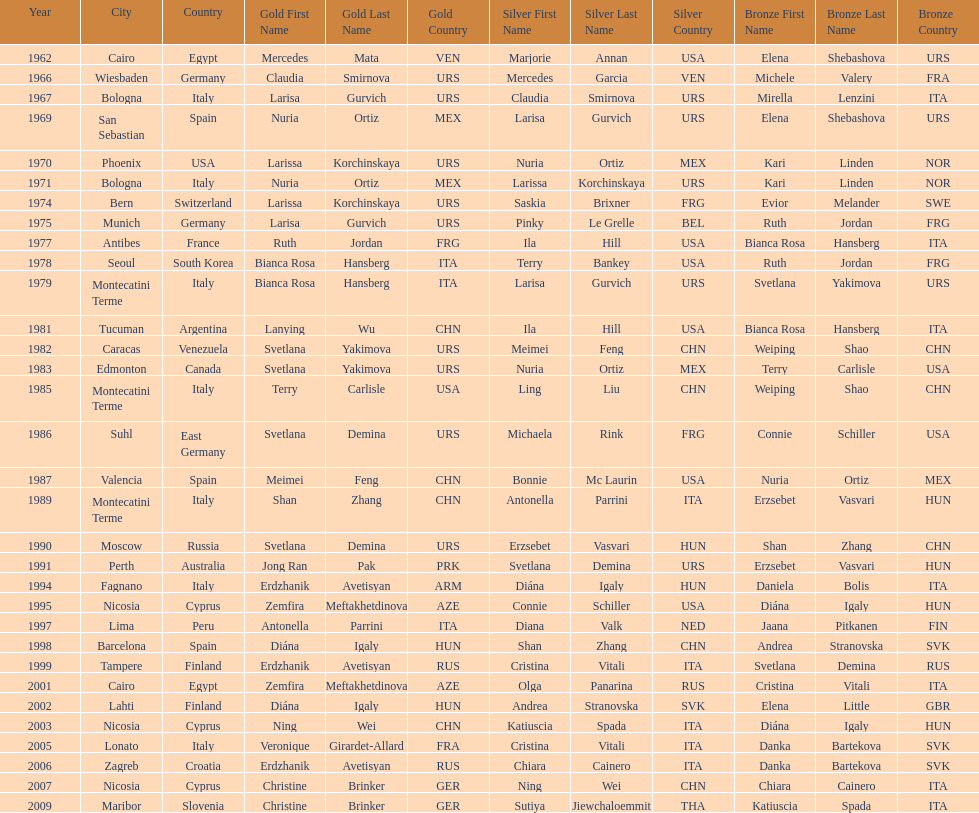Who won the only gold medal in 1962? Mercedes Mata. 